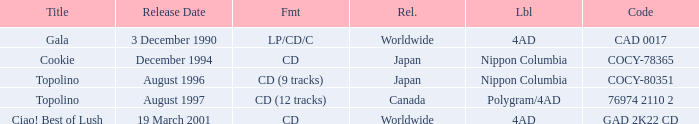What Label has a Code of cocy-78365? Nippon Columbia. 